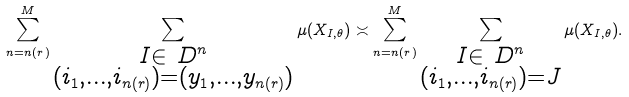Convert formula to latex. <formula><loc_0><loc_0><loc_500><loc_500>\sum _ { n = n ( r ) } ^ { M } \sum _ { \substack { I \in \ D ^ { n } \\ ( i _ { 1 } , \dots , i _ { n ( r ) } ) = ( y _ { 1 } , \dots , y _ { n ( r ) } ) } } \mu ( X _ { I , \theta } ) \asymp \sum _ { n = n ( r ) } ^ { M } \sum _ { \substack { I \in \ D ^ { n } \\ ( i _ { 1 } , \dots , i _ { n ( r ) } ) = J } } \mu ( X _ { I , \theta } ) .</formula> 